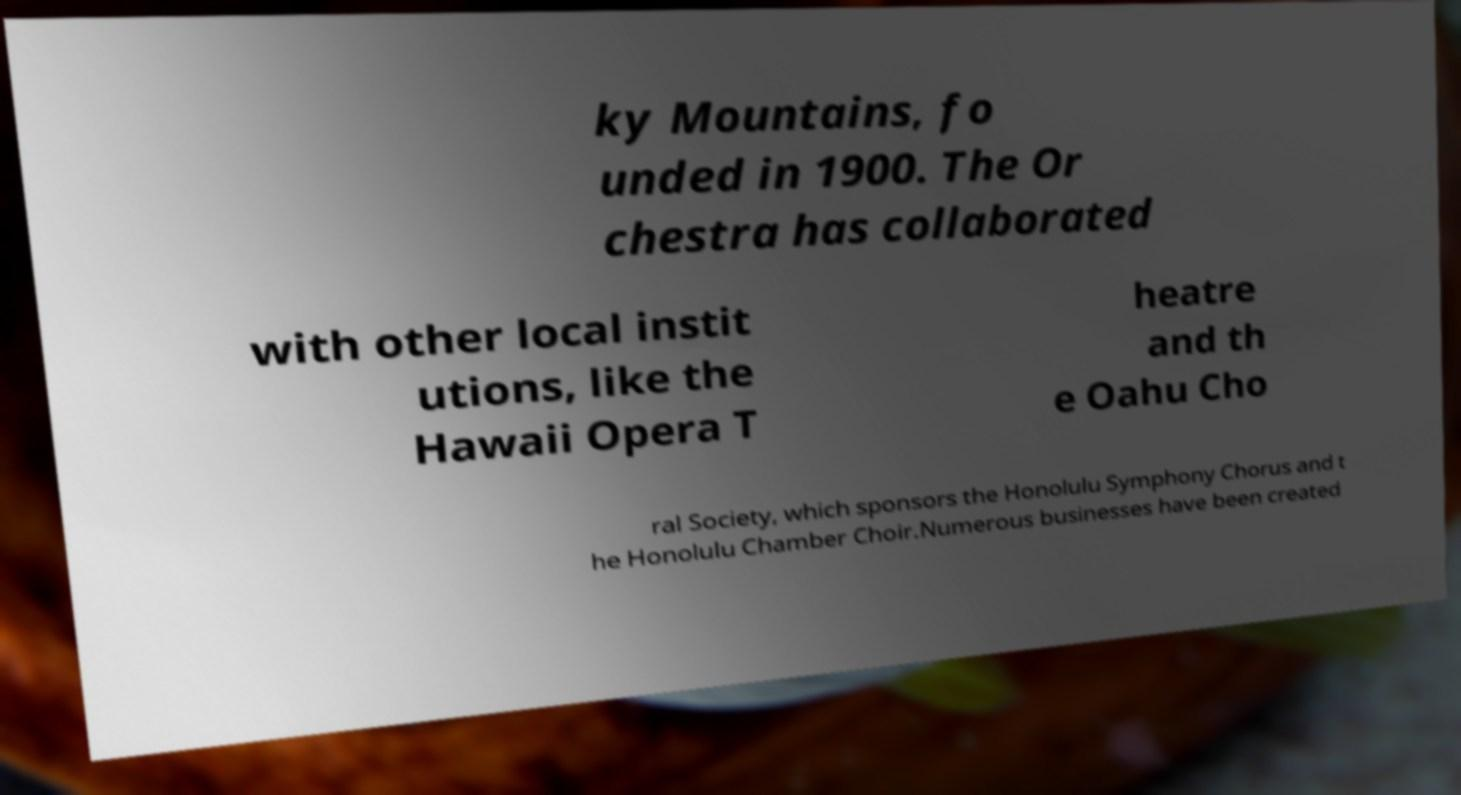Please read and relay the text visible in this image. What does it say? ky Mountains, fo unded in 1900. The Or chestra has collaborated with other local instit utions, like the Hawaii Opera T heatre and th e Oahu Cho ral Society, which sponsors the Honolulu Symphony Chorus and t he Honolulu Chamber Choir.Numerous businesses have been created 